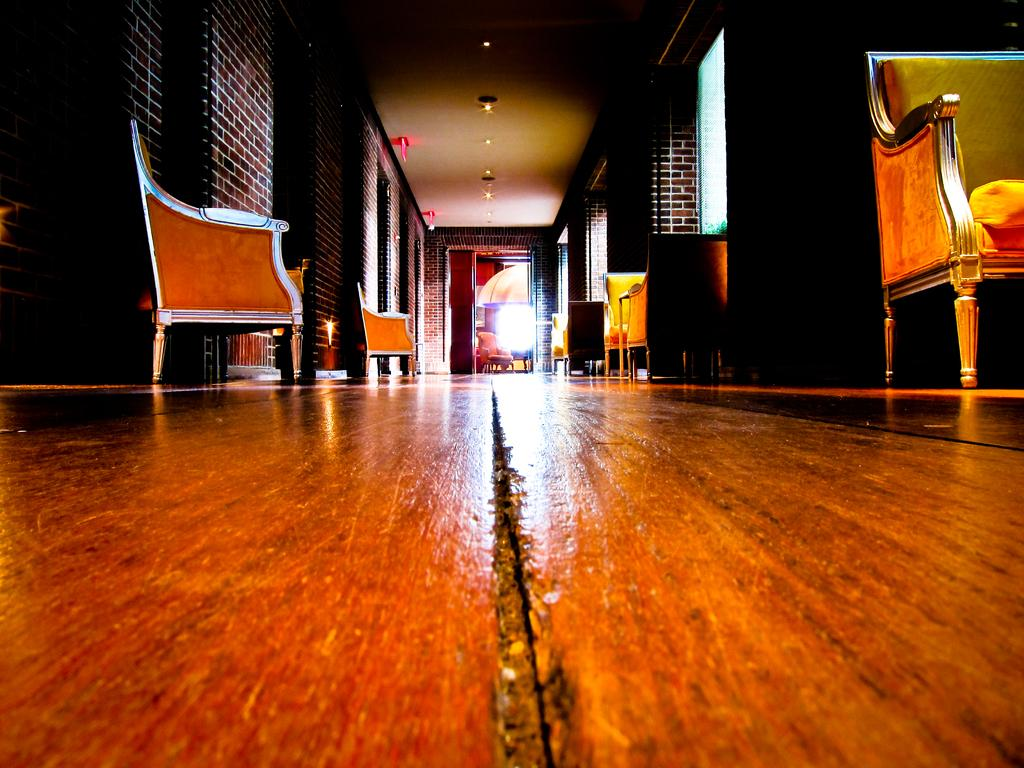What type of furniture is present in the image? There are chairs in the image. What architectural features can be seen in the image? There are windows, doors, and a brick wall in the image. What lighting elements are visible in the image? There are lights and a candle in the image. What type of flooring is present in the image? There is a wooden floor in the image. What time of day is it in the image, and is the grandfather present with his cub? The time of day is not mentioned in the image, and there is no mention of a grandfather or a cub. 